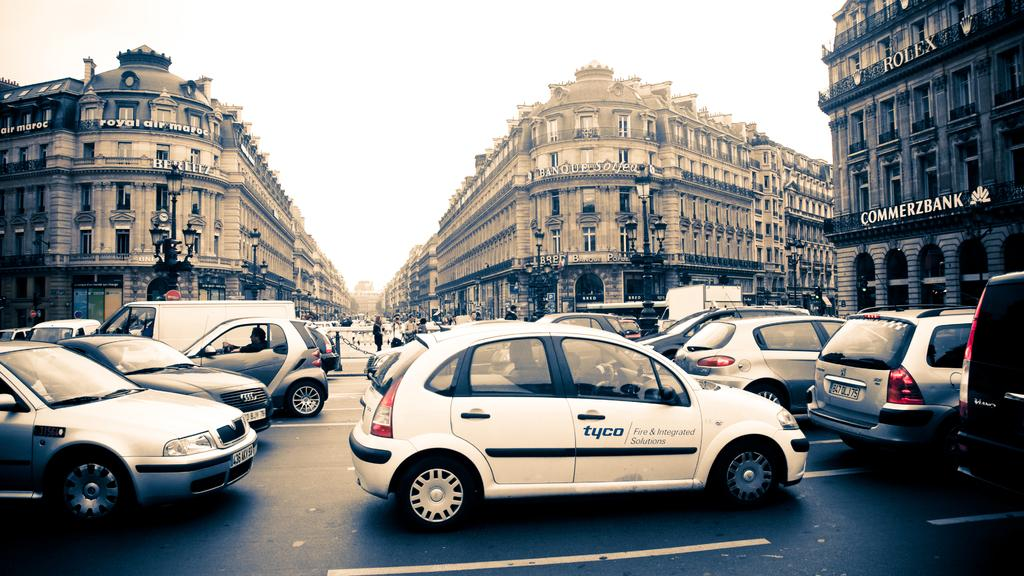Provide a one-sentence caption for the provided image. cars on a european street where one is from Tyco. 